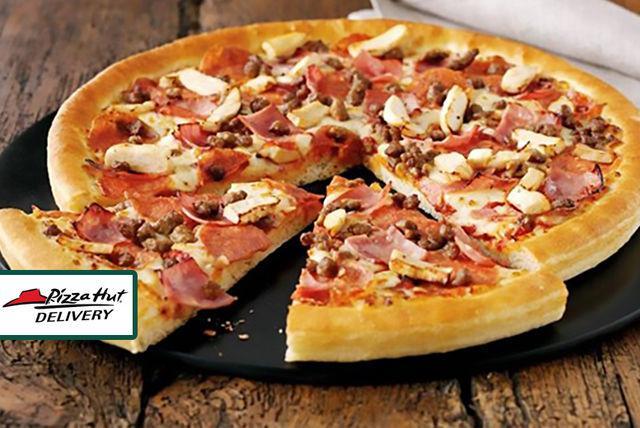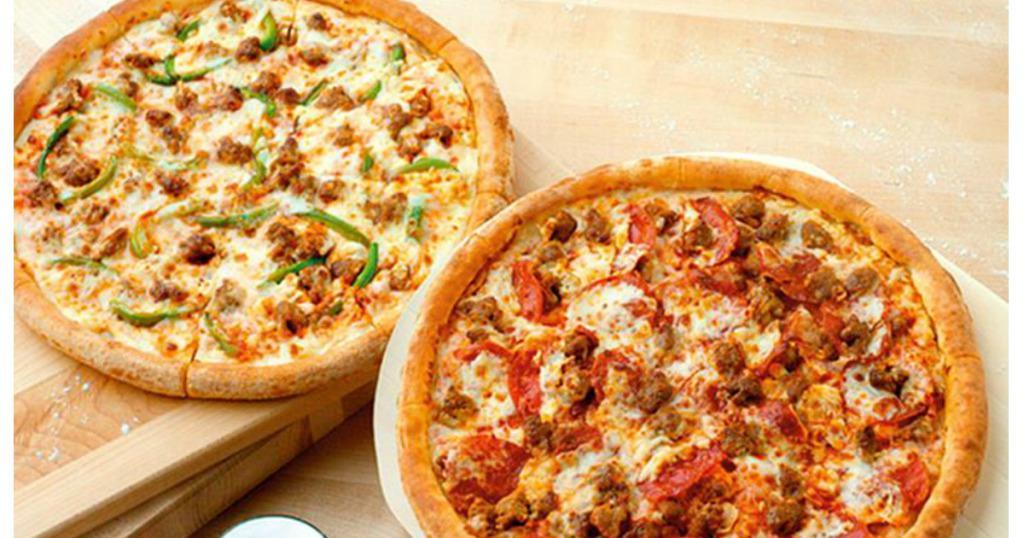The first image is the image on the left, the second image is the image on the right. Given the left and right images, does the statement "Exactly one pizza contains pepperoni." hold true? Answer yes or no. No. The first image is the image on the left, the second image is the image on the right. Examine the images to the left and right. Is the description "There are more pizzas in the image on the left." accurate? Answer yes or no. No. 